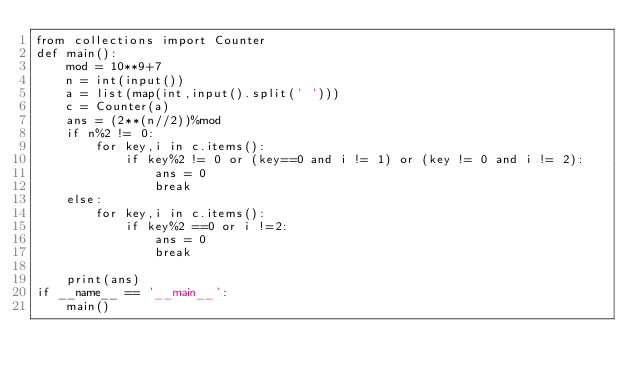<code> <loc_0><loc_0><loc_500><loc_500><_Python_>from collections import Counter
def main():
    mod = 10**9+7
    n = int(input())
    a = list(map(int,input().split(' ')))
    c = Counter(a)
    ans = (2**(n//2))%mod
    if n%2 != 0:
        for key,i in c.items():
            if key%2 != 0 or (key==0 and i != 1) or (key != 0 and i != 2):
                ans = 0
                break
    else:
        for key,i in c.items():
            if key%2 ==0 or i !=2:
                ans = 0
                break

    print(ans)
if __name__ == '__main__':
    main()</code> 